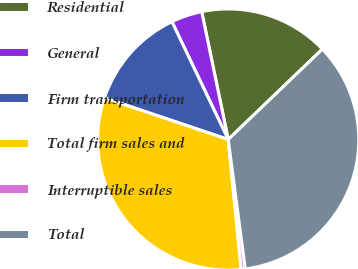Convert chart to OTSL. <chart><loc_0><loc_0><loc_500><loc_500><pie_chart><fcel>Residential<fcel>General<fcel>Firm transportation<fcel>Total firm sales and<fcel>Interruptible sales<fcel>Total<nl><fcel>16.08%<fcel>3.84%<fcel>12.74%<fcel>31.76%<fcel>0.5%<fcel>35.1%<nl></chart> 